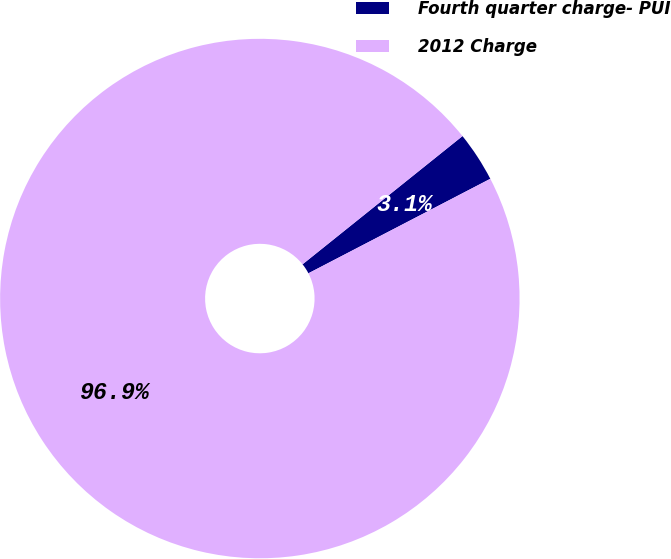Convert chart to OTSL. <chart><loc_0><loc_0><loc_500><loc_500><pie_chart><fcel>Fourth quarter charge- PUI<fcel>2012 Charge<nl><fcel>3.13%<fcel>96.87%<nl></chart> 